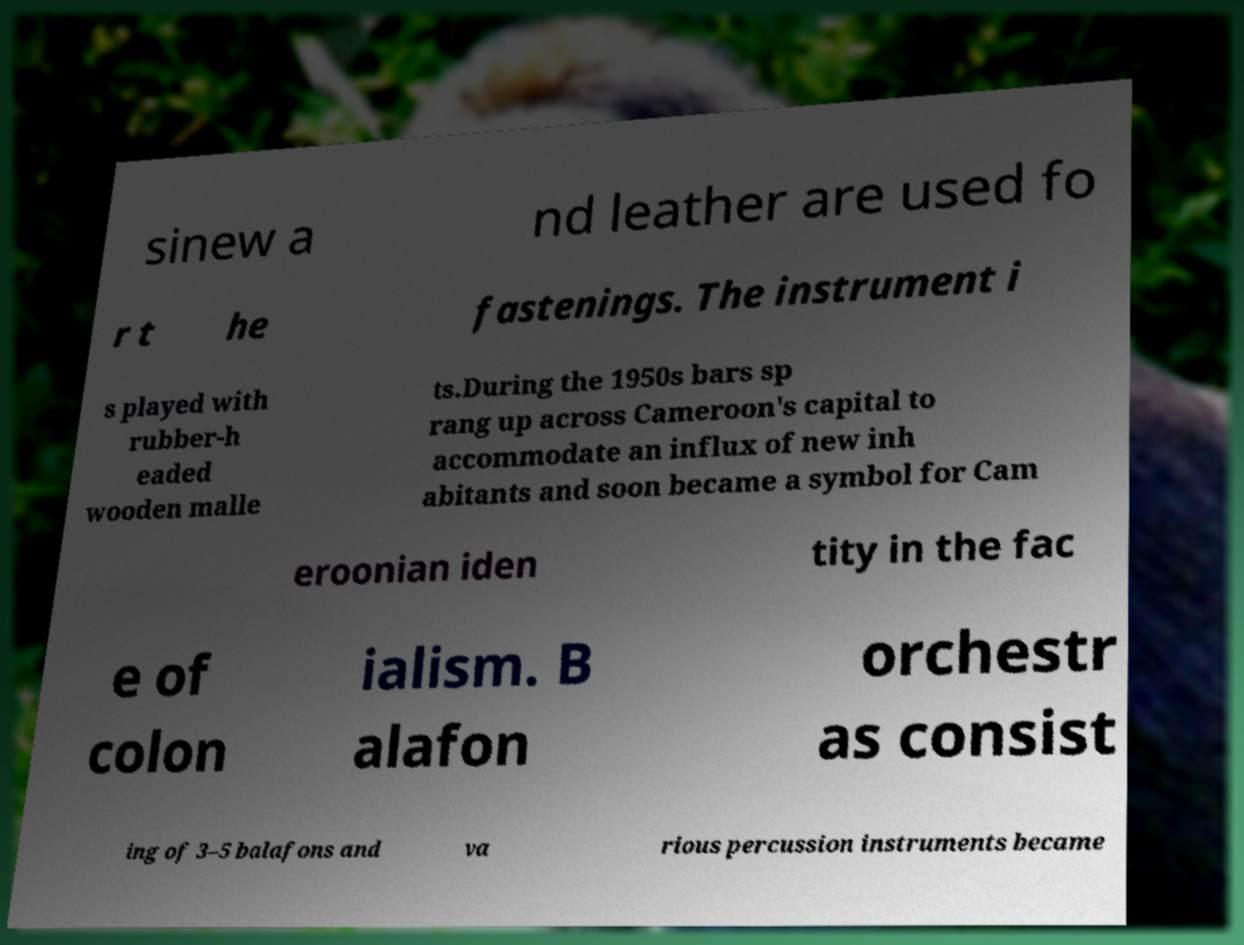Can you accurately transcribe the text from the provided image for me? sinew a nd leather are used fo r t he fastenings. The instrument i s played with rubber-h eaded wooden malle ts.During the 1950s bars sp rang up across Cameroon's capital to accommodate an influx of new inh abitants and soon became a symbol for Cam eroonian iden tity in the fac e of colon ialism. B alafon orchestr as consist ing of 3–5 balafons and va rious percussion instruments became 